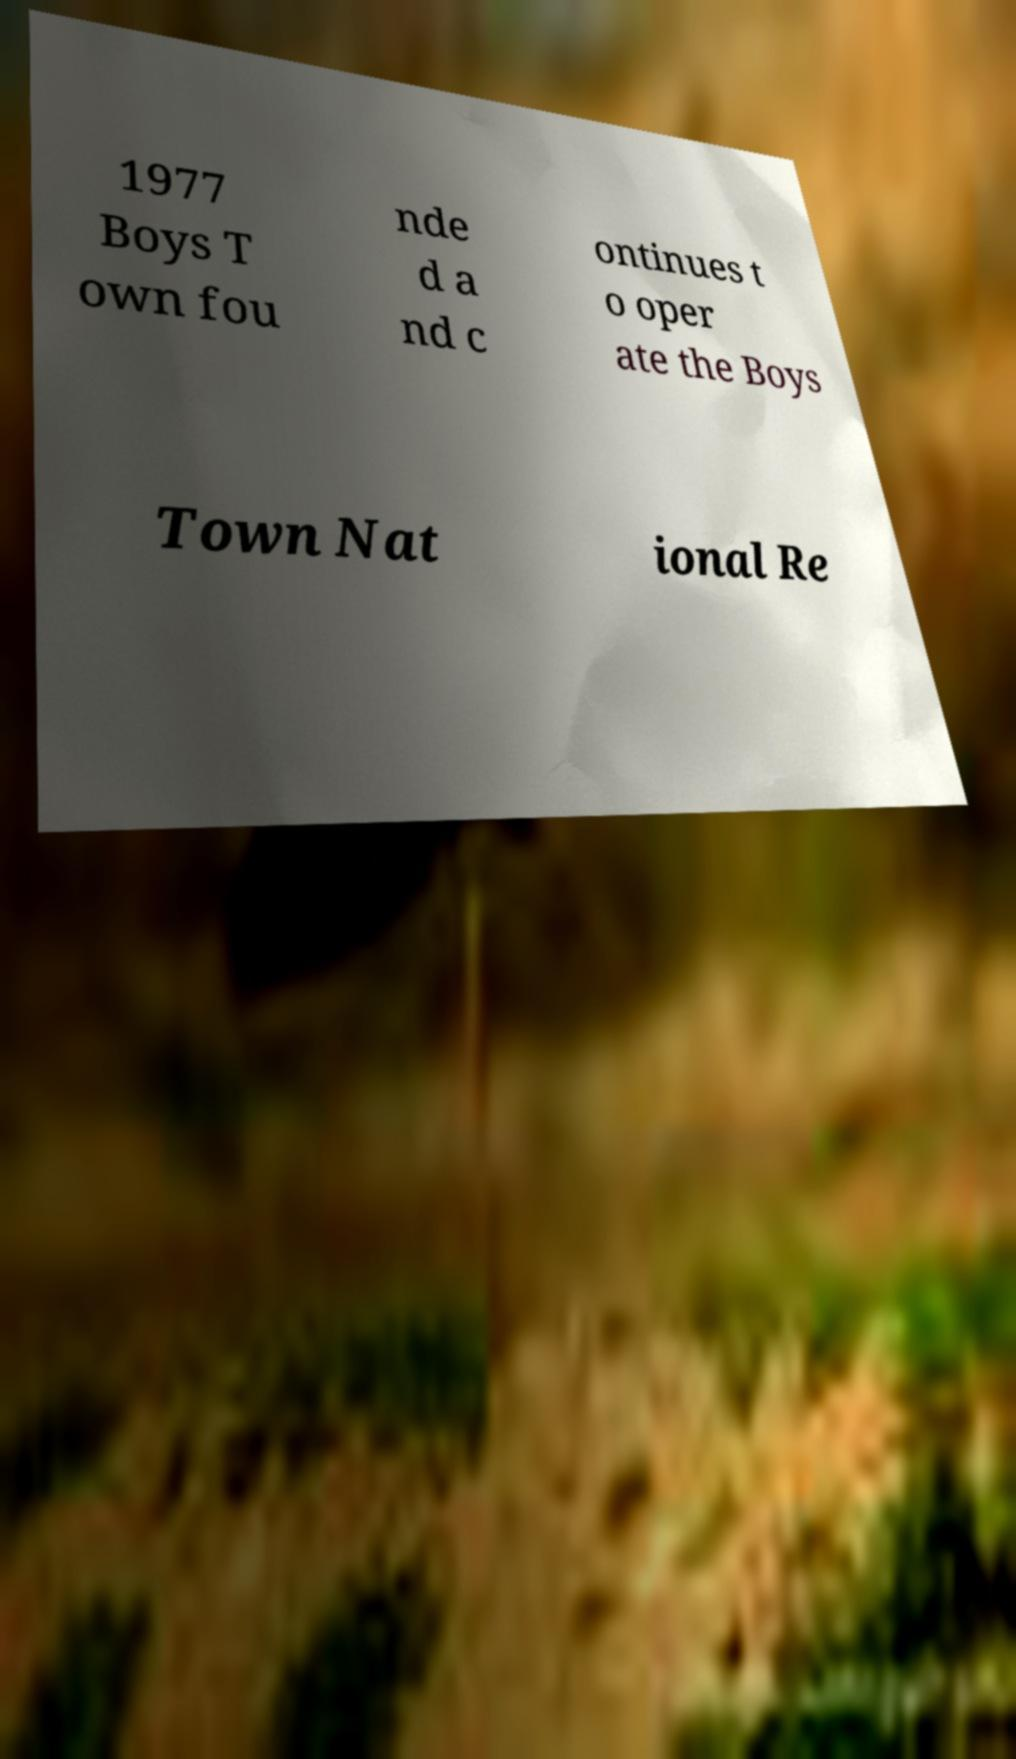Could you assist in decoding the text presented in this image and type it out clearly? 1977 Boys T own fou nde d a nd c ontinues t o oper ate the Boys Town Nat ional Re 